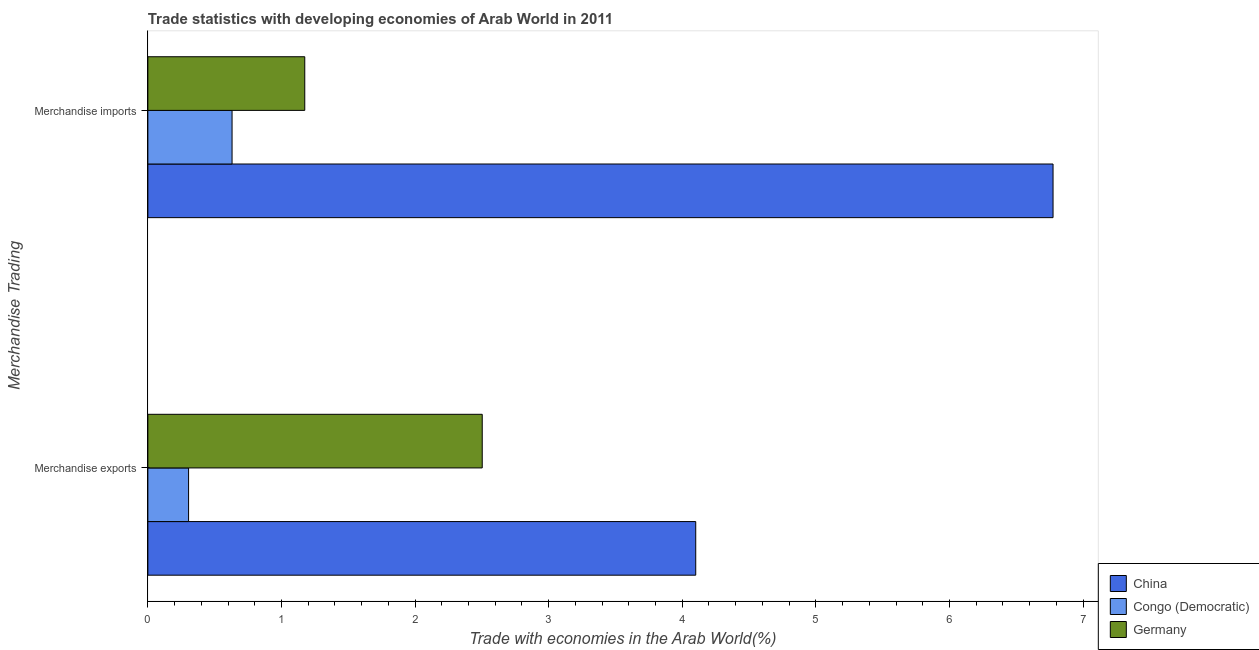How many groups of bars are there?
Give a very brief answer. 2. Are the number of bars on each tick of the Y-axis equal?
Your answer should be very brief. Yes. How many bars are there on the 1st tick from the top?
Give a very brief answer. 3. What is the label of the 1st group of bars from the top?
Offer a very short reply. Merchandise imports. What is the merchandise imports in Congo (Democratic)?
Your answer should be very brief. 0.63. Across all countries, what is the maximum merchandise imports?
Keep it short and to the point. 6.78. Across all countries, what is the minimum merchandise imports?
Your response must be concise. 0.63. In which country was the merchandise exports minimum?
Offer a very short reply. Congo (Democratic). What is the total merchandise imports in the graph?
Your answer should be very brief. 8.58. What is the difference between the merchandise imports in Congo (Democratic) and that in China?
Give a very brief answer. -6.15. What is the difference between the merchandise exports in China and the merchandise imports in Congo (Democratic)?
Your response must be concise. 3.47. What is the average merchandise imports per country?
Keep it short and to the point. 2.86. What is the difference between the merchandise exports and merchandise imports in Congo (Democratic)?
Give a very brief answer. -0.33. In how many countries, is the merchandise exports greater than 1.2 %?
Keep it short and to the point. 2. What is the ratio of the merchandise exports in China to that in Germany?
Your answer should be very brief. 1.64. Is the merchandise imports in China less than that in Germany?
Offer a terse response. No. Are all the bars in the graph horizontal?
Offer a terse response. Yes. How many countries are there in the graph?
Keep it short and to the point. 3. What is the difference between two consecutive major ticks on the X-axis?
Ensure brevity in your answer.  1. Are the values on the major ticks of X-axis written in scientific E-notation?
Offer a terse response. No. Does the graph contain grids?
Keep it short and to the point. No. Where does the legend appear in the graph?
Provide a succinct answer. Bottom right. How many legend labels are there?
Your answer should be compact. 3. How are the legend labels stacked?
Provide a succinct answer. Vertical. What is the title of the graph?
Give a very brief answer. Trade statistics with developing economies of Arab World in 2011. Does "Romania" appear as one of the legend labels in the graph?
Provide a succinct answer. No. What is the label or title of the X-axis?
Your response must be concise. Trade with economies in the Arab World(%). What is the label or title of the Y-axis?
Your answer should be very brief. Merchandise Trading. What is the Trade with economies in the Arab World(%) of China in Merchandise exports?
Make the answer very short. 4.1. What is the Trade with economies in the Arab World(%) of Congo (Democratic) in Merchandise exports?
Offer a terse response. 0.3. What is the Trade with economies in the Arab World(%) of Germany in Merchandise exports?
Offer a very short reply. 2.5. What is the Trade with economies in the Arab World(%) of China in Merchandise imports?
Offer a terse response. 6.78. What is the Trade with economies in the Arab World(%) of Congo (Democratic) in Merchandise imports?
Make the answer very short. 0.63. What is the Trade with economies in the Arab World(%) of Germany in Merchandise imports?
Provide a short and direct response. 1.17. Across all Merchandise Trading, what is the maximum Trade with economies in the Arab World(%) of China?
Ensure brevity in your answer.  6.78. Across all Merchandise Trading, what is the maximum Trade with economies in the Arab World(%) in Congo (Democratic)?
Provide a succinct answer. 0.63. Across all Merchandise Trading, what is the maximum Trade with economies in the Arab World(%) in Germany?
Offer a very short reply. 2.5. Across all Merchandise Trading, what is the minimum Trade with economies in the Arab World(%) in China?
Give a very brief answer. 4.1. Across all Merchandise Trading, what is the minimum Trade with economies in the Arab World(%) of Congo (Democratic)?
Keep it short and to the point. 0.3. Across all Merchandise Trading, what is the minimum Trade with economies in the Arab World(%) in Germany?
Your answer should be very brief. 1.17. What is the total Trade with economies in the Arab World(%) of China in the graph?
Your answer should be compact. 10.88. What is the total Trade with economies in the Arab World(%) in Congo (Democratic) in the graph?
Provide a succinct answer. 0.93. What is the total Trade with economies in the Arab World(%) of Germany in the graph?
Your answer should be very brief. 3.68. What is the difference between the Trade with economies in the Arab World(%) of China in Merchandise exports and that in Merchandise imports?
Ensure brevity in your answer.  -2.67. What is the difference between the Trade with economies in the Arab World(%) in Congo (Democratic) in Merchandise exports and that in Merchandise imports?
Offer a terse response. -0.33. What is the difference between the Trade with economies in the Arab World(%) in Germany in Merchandise exports and that in Merchandise imports?
Your answer should be compact. 1.33. What is the difference between the Trade with economies in the Arab World(%) of China in Merchandise exports and the Trade with economies in the Arab World(%) of Congo (Democratic) in Merchandise imports?
Offer a terse response. 3.47. What is the difference between the Trade with economies in the Arab World(%) in China in Merchandise exports and the Trade with economies in the Arab World(%) in Germany in Merchandise imports?
Offer a terse response. 2.93. What is the difference between the Trade with economies in the Arab World(%) in Congo (Democratic) in Merchandise exports and the Trade with economies in the Arab World(%) in Germany in Merchandise imports?
Your answer should be compact. -0.87. What is the average Trade with economies in the Arab World(%) in China per Merchandise Trading?
Offer a terse response. 5.44. What is the average Trade with economies in the Arab World(%) of Congo (Democratic) per Merchandise Trading?
Your answer should be compact. 0.47. What is the average Trade with economies in the Arab World(%) of Germany per Merchandise Trading?
Give a very brief answer. 1.84. What is the difference between the Trade with economies in the Arab World(%) of China and Trade with economies in the Arab World(%) of Congo (Democratic) in Merchandise exports?
Keep it short and to the point. 3.8. What is the difference between the Trade with economies in the Arab World(%) of China and Trade with economies in the Arab World(%) of Germany in Merchandise exports?
Ensure brevity in your answer.  1.6. What is the difference between the Trade with economies in the Arab World(%) of Congo (Democratic) and Trade with economies in the Arab World(%) of Germany in Merchandise exports?
Keep it short and to the point. -2.2. What is the difference between the Trade with economies in the Arab World(%) of China and Trade with economies in the Arab World(%) of Congo (Democratic) in Merchandise imports?
Your answer should be compact. 6.15. What is the difference between the Trade with economies in the Arab World(%) of China and Trade with economies in the Arab World(%) of Germany in Merchandise imports?
Provide a succinct answer. 5.6. What is the difference between the Trade with economies in the Arab World(%) of Congo (Democratic) and Trade with economies in the Arab World(%) of Germany in Merchandise imports?
Offer a terse response. -0.54. What is the ratio of the Trade with economies in the Arab World(%) in China in Merchandise exports to that in Merchandise imports?
Provide a short and direct response. 0.61. What is the ratio of the Trade with economies in the Arab World(%) in Congo (Democratic) in Merchandise exports to that in Merchandise imports?
Make the answer very short. 0.48. What is the ratio of the Trade with economies in the Arab World(%) in Germany in Merchandise exports to that in Merchandise imports?
Give a very brief answer. 2.13. What is the difference between the highest and the second highest Trade with economies in the Arab World(%) of China?
Ensure brevity in your answer.  2.67. What is the difference between the highest and the second highest Trade with economies in the Arab World(%) of Congo (Democratic)?
Your response must be concise. 0.33. What is the difference between the highest and the second highest Trade with economies in the Arab World(%) in Germany?
Provide a short and direct response. 1.33. What is the difference between the highest and the lowest Trade with economies in the Arab World(%) of China?
Your response must be concise. 2.67. What is the difference between the highest and the lowest Trade with economies in the Arab World(%) of Congo (Democratic)?
Your answer should be compact. 0.33. What is the difference between the highest and the lowest Trade with economies in the Arab World(%) in Germany?
Give a very brief answer. 1.33. 